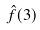Convert formula to latex. <formula><loc_0><loc_0><loc_500><loc_500>\hat { f } ( 3 )</formula> 